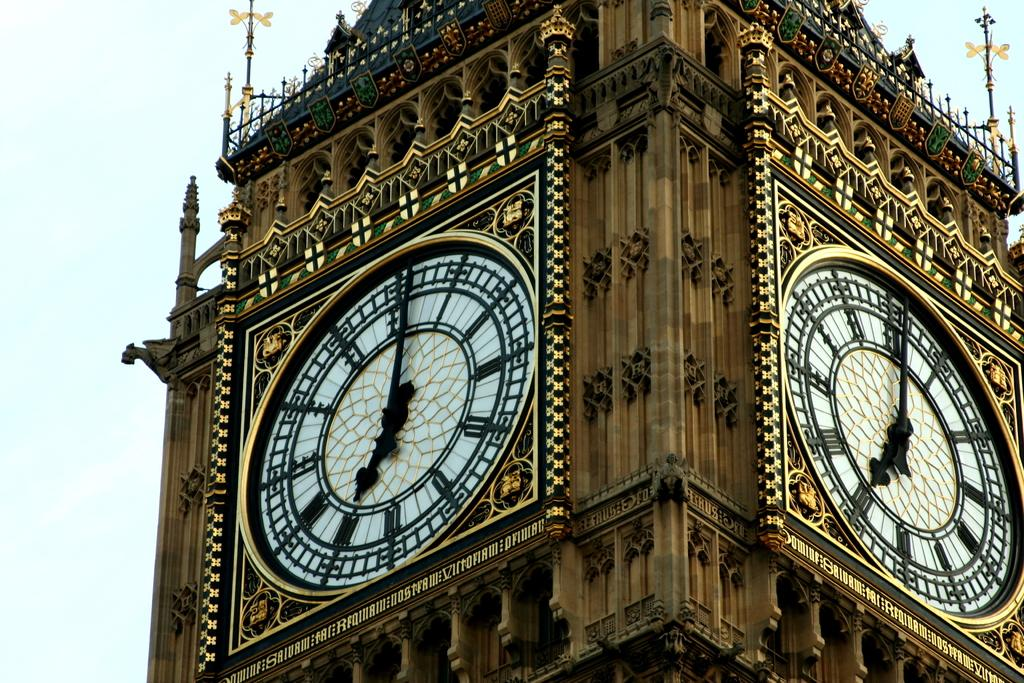What is the main structure in the picture? There is a clock tower in the picture. How many clock faces are on the clock tower? The clock tower has two sides with clocks. What other artistic elements are present around the clock tower? There are art and sculptures around the clock tower. What can be seen in the sky beside the clock tower? The sky is visible beside the clock tower. What type of worm can be seen crawling on the clock tower in the image? There are no worms present on the clock tower in the image. 